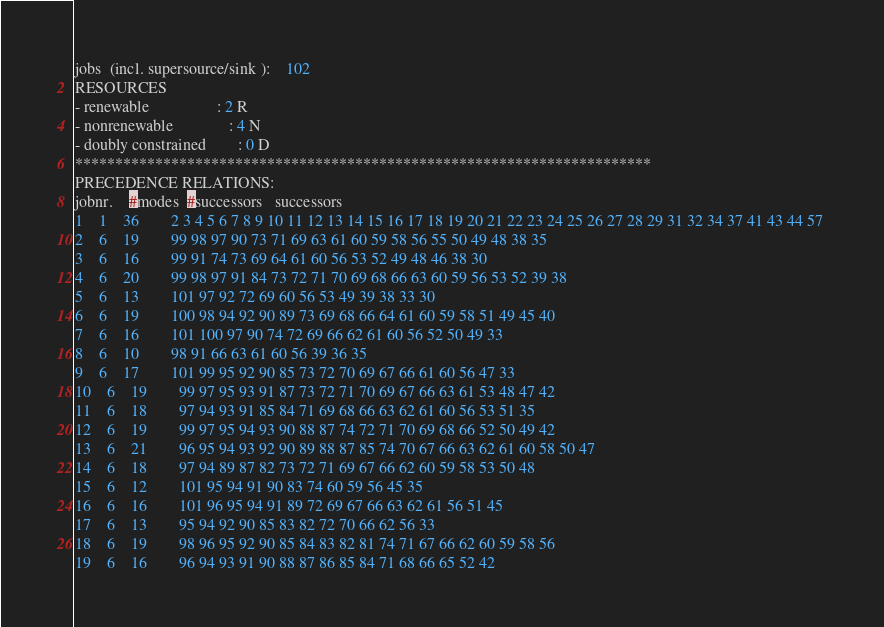Convert code to text. <code><loc_0><loc_0><loc_500><loc_500><_ObjectiveC_>jobs  (incl. supersource/sink ):	102
RESOURCES
- renewable                 : 2 R
- nonrenewable              : 4 N
- doubly constrained        : 0 D
************************************************************************
PRECEDENCE RELATIONS:
jobnr.    #modes  #successors   successors
1	1	36		2 3 4 5 6 7 8 9 10 11 12 13 14 15 16 17 18 19 20 21 22 23 24 25 26 27 28 29 31 32 34 37 41 43 44 57 
2	6	19		99 98 97 90 73 71 69 63 61 60 59 58 56 55 50 49 48 38 35 
3	6	16		99 91 74 73 69 64 61 60 56 53 52 49 48 46 38 30 
4	6	20		99 98 97 91 84 73 72 71 70 69 68 66 63 60 59 56 53 52 39 38 
5	6	13		101 97 92 72 69 60 56 53 49 39 38 33 30 
6	6	19		100 98 94 92 90 89 73 69 68 66 64 61 60 59 58 51 49 45 40 
7	6	16		101 100 97 90 74 72 69 66 62 61 60 56 52 50 49 33 
8	6	10		98 91 66 63 61 60 56 39 36 35 
9	6	17		101 99 95 92 90 85 73 72 70 69 67 66 61 60 56 47 33 
10	6	19		99 97 95 93 91 87 73 72 71 70 69 67 66 63 61 53 48 47 42 
11	6	18		97 94 93 91 85 84 71 69 68 66 63 62 61 60 56 53 51 35 
12	6	19		99 97 95 94 93 90 88 87 74 72 71 70 69 68 66 52 50 49 42 
13	6	21		96 95 94 93 92 90 89 88 87 85 74 70 67 66 63 62 61 60 58 50 47 
14	6	18		97 94 89 87 82 73 72 71 69 67 66 62 60 59 58 53 50 48 
15	6	12		101 95 94 91 90 83 74 60 59 56 45 35 
16	6	16		101 96 95 94 91 89 72 69 67 66 63 62 61 56 51 45 
17	6	13		95 94 92 90 85 83 82 72 70 66 62 56 33 
18	6	19		98 96 95 92 90 85 84 83 82 81 74 71 67 66 62 60 59 58 56 
19	6	16		96 94 93 91 90 88 87 86 85 84 71 68 66 65 52 42 </code> 